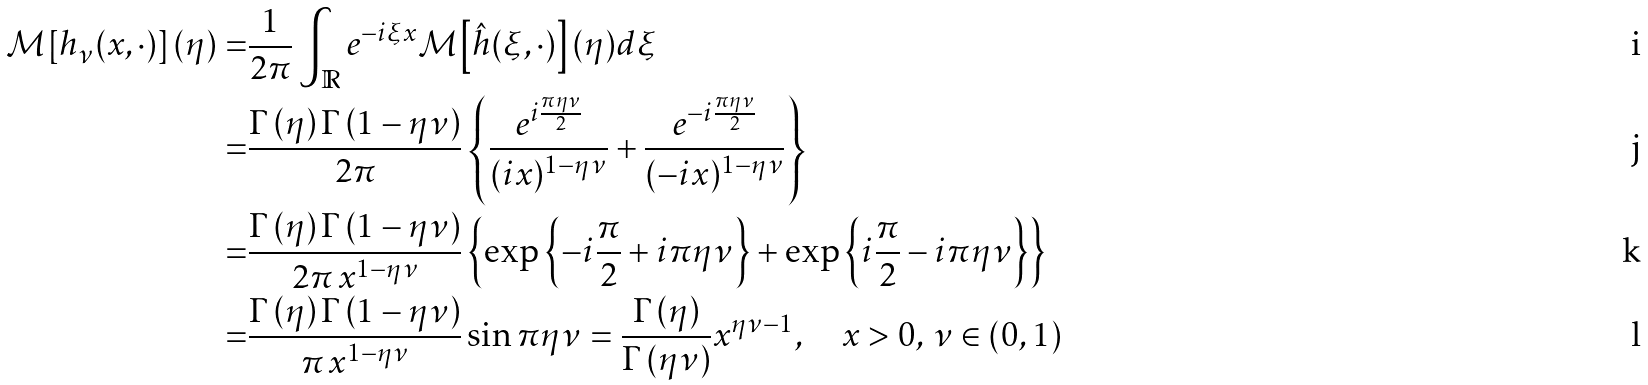<formula> <loc_0><loc_0><loc_500><loc_500>\mathcal { M } \left [ h _ { \nu } ( x , \cdot ) \right ] ( \eta ) = & \frac { 1 } { 2 \pi } \int _ { \mathbb { R } } e ^ { - i \xi x } \mathcal { M } \left [ \hat { h } ( \xi , \cdot ) \right ] ( \eta ) d \xi \\ = & \frac { \Gamma \left ( \eta \right ) \Gamma \left ( 1 - \eta \nu \right ) } { 2 \pi } \left \{ \frac { e ^ { i \frac { \pi \eta \nu } { 2 } } } { ( i x ) ^ { 1 - \eta \nu } } + \frac { e ^ { - i \frac { \pi \eta \nu } { 2 } } } { ( - i x ) ^ { 1 - \eta \nu } } \right \} \\ = & \frac { \Gamma \left ( \eta \right ) \Gamma \left ( 1 - \eta \nu \right ) } { 2 \pi \, x ^ { 1 - \eta \nu } } \left \{ \exp \left \{ - i \frac { \pi } { 2 } + i \pi \eta \nu \right \} + \exp \left \{ i \frac { \pi } { 2 } - i \pi \eta \nu \right \} \right \} \\ = & \frac { \Gamma \left ( \eta \right ) \Gamma \left ( 1 - \eta \nu \right ) } { \pi \, x ^ { 1 - \eta \nu } } \sin \pi \eta \nu = \frac { \Gamma \left ( \eta \right ) } { \Gamma \left ( \eta \nu \right ) } x ^ { \eta \nu - 1 } , \quad x > 0 , \, \nu \in ( 0 , 1 )</formula> 